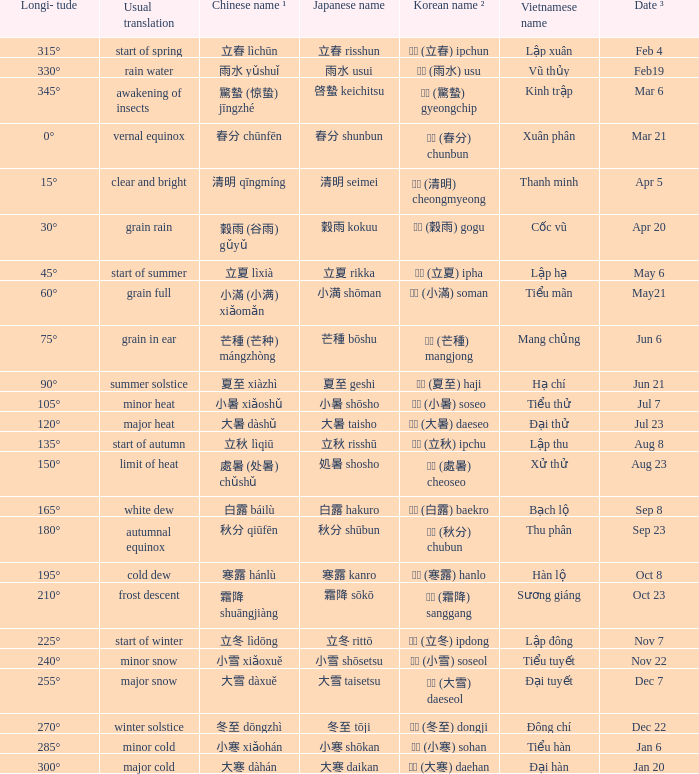WHich Usual translation is on sep 23? Autumnal equinox. 